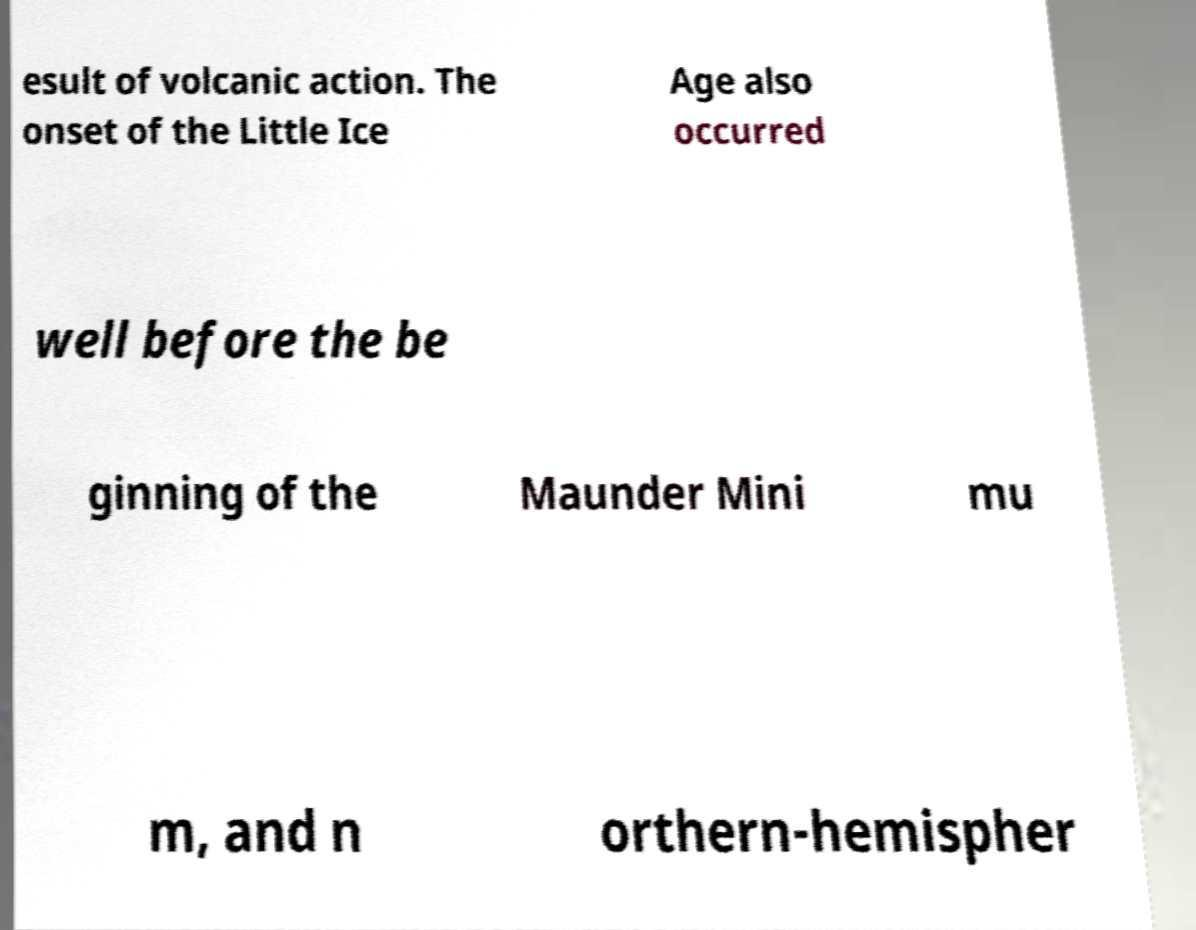Can you accurately transcribe the text from the provided image for me? esult of volcanic action. The onset of the Little Ice Age also occurred well before the be ginning of the Maunder Mini mu m, and n orthern-hemispher 